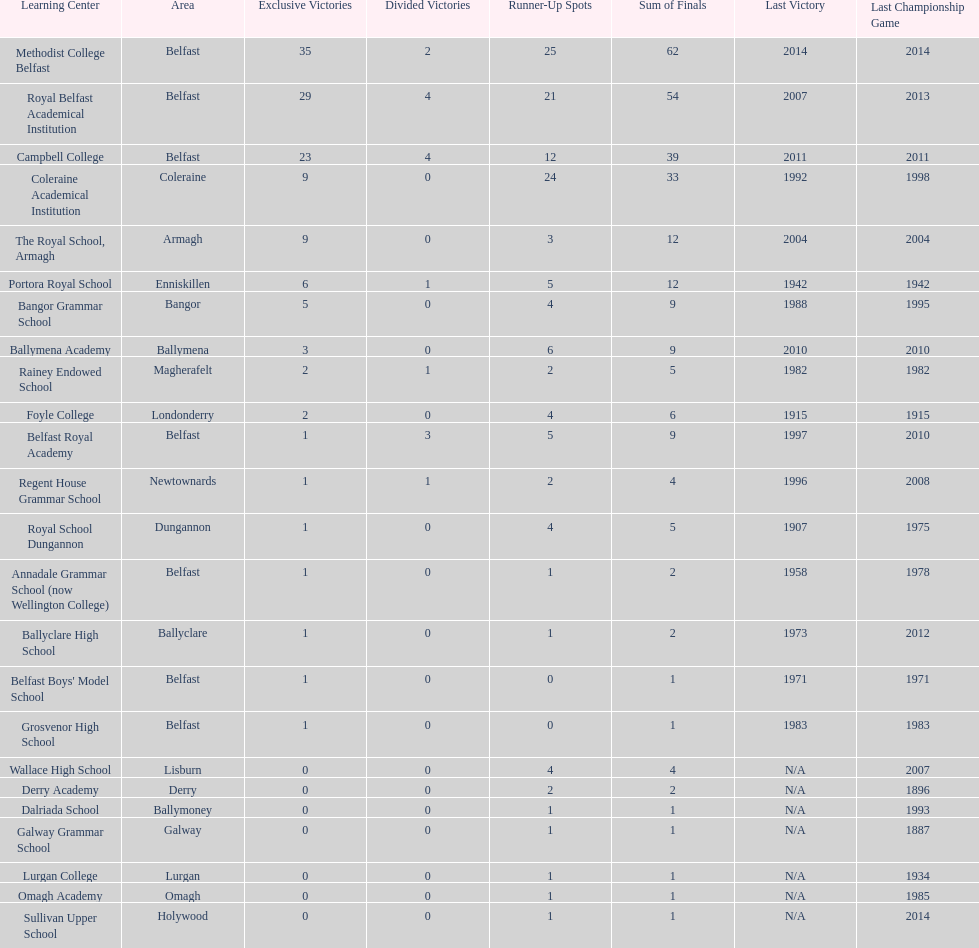Which schools have the largest number of shared titles? Royal Belfast Academical Institution, Campbell College. 